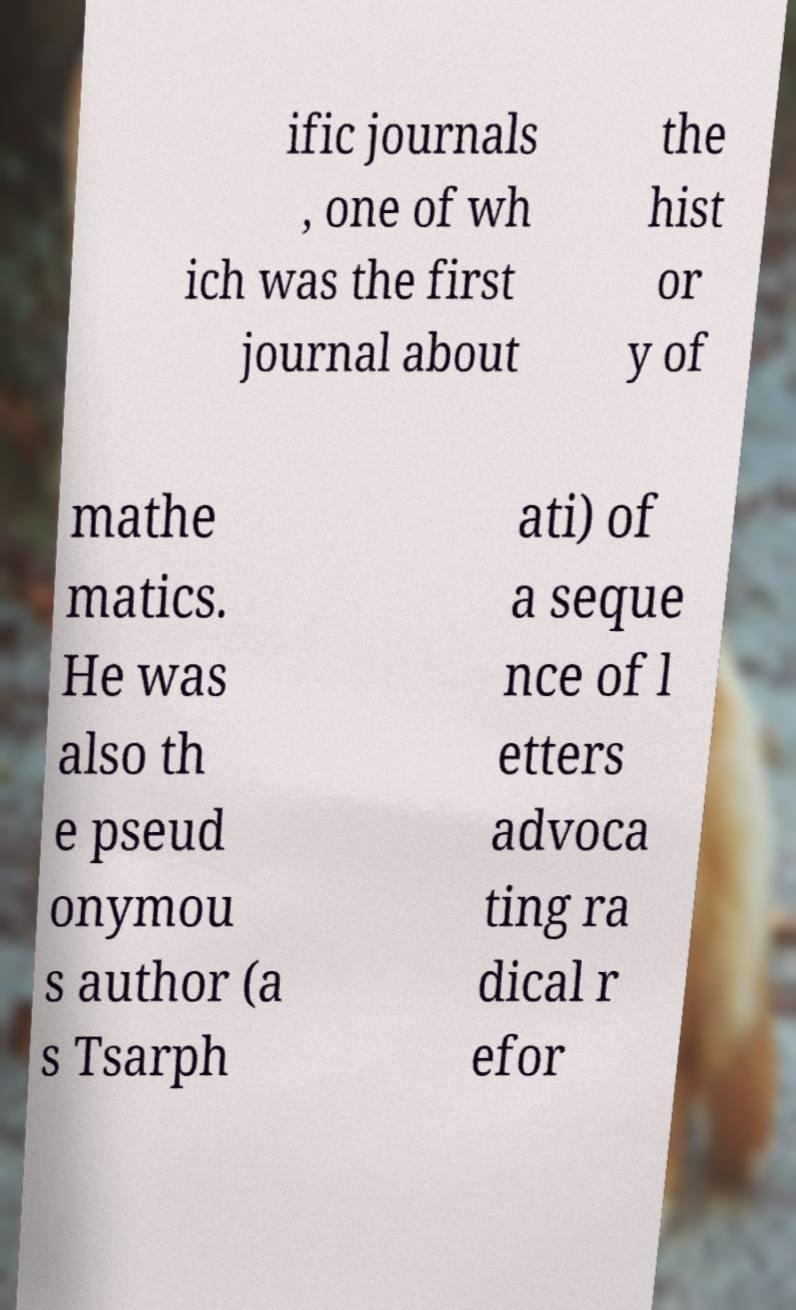I need the written content from this picture converted into text. Can you do that? ific journals , one of wh ich was the first journal about the hist or y of mathe matics. He was also th e pseud onymou s author (a s Tsarph ati) of a seque nce of l etters advoca ting ra dical r efor 